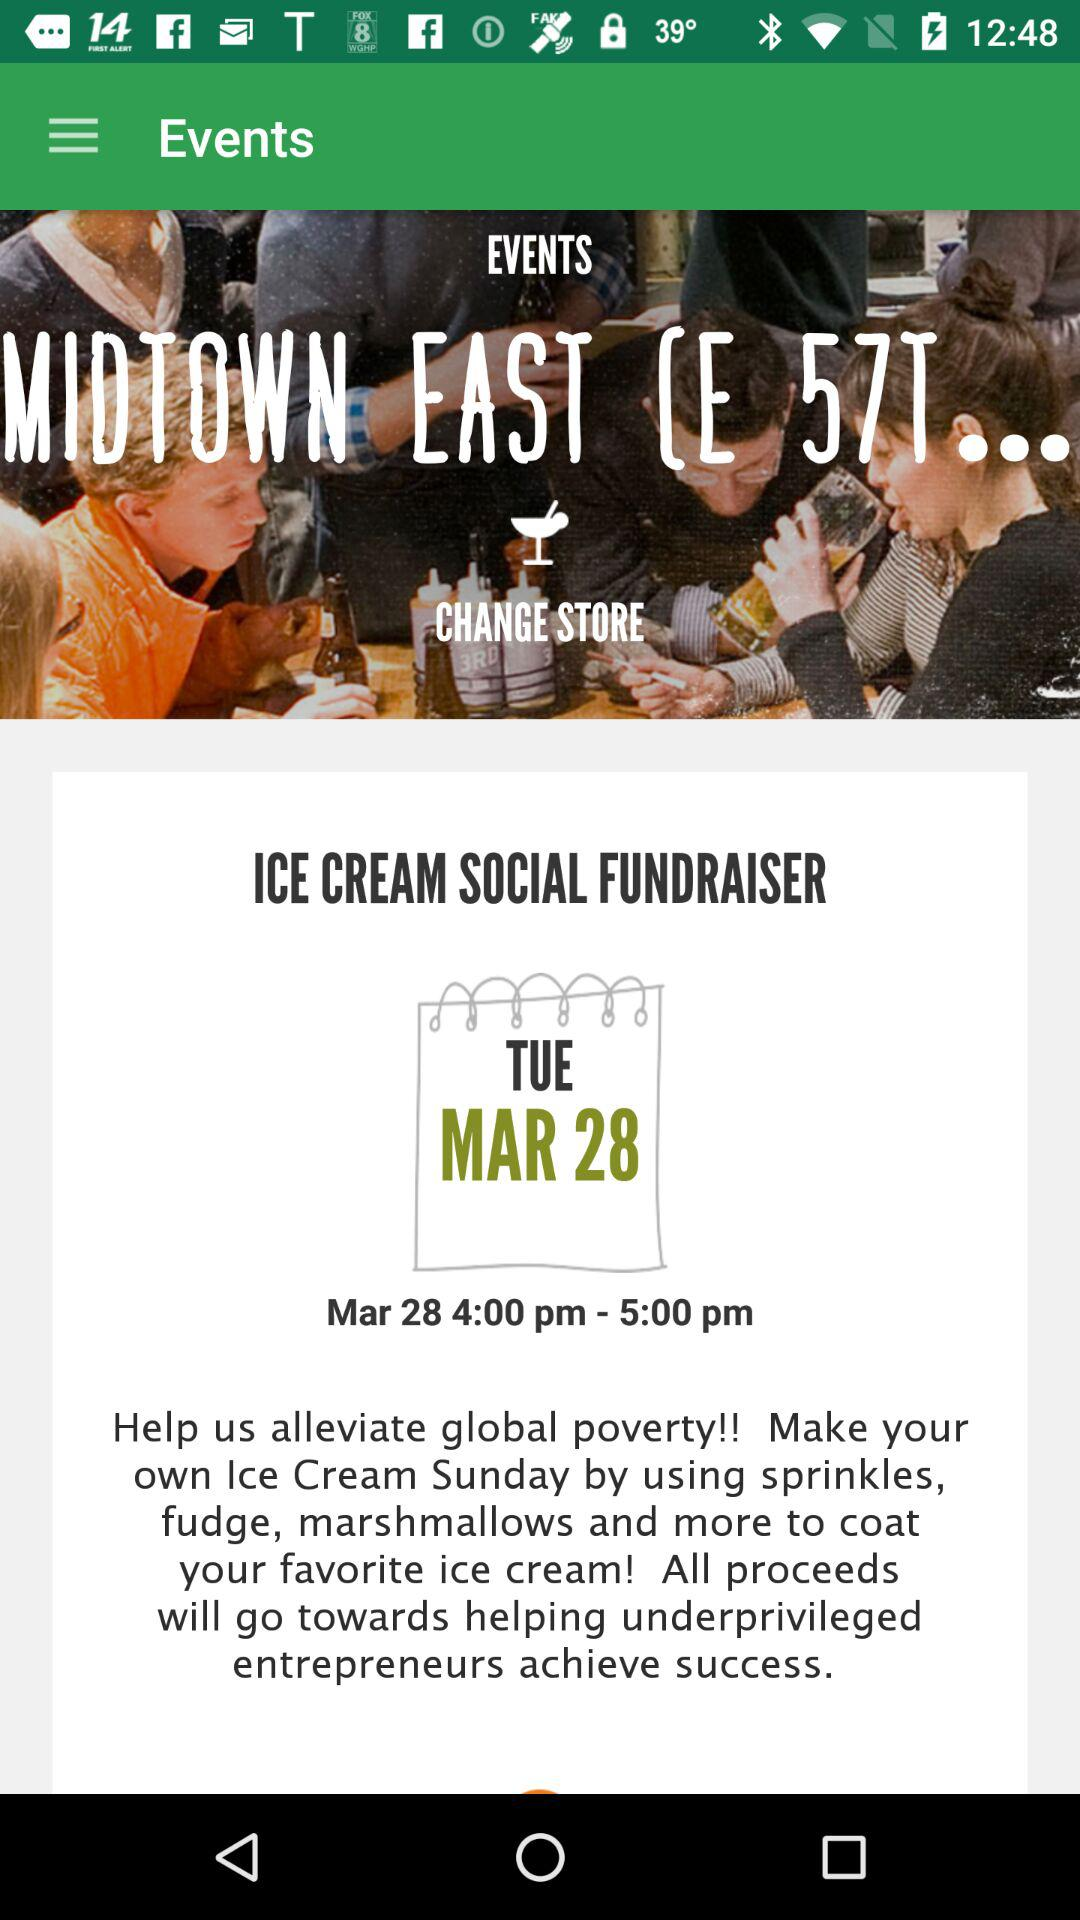What is the date and time of the scheduled event? The date of the scheduled event is Tuesday, March 28 and the time is from 4:00 p.m. to 5:00 p.m. 